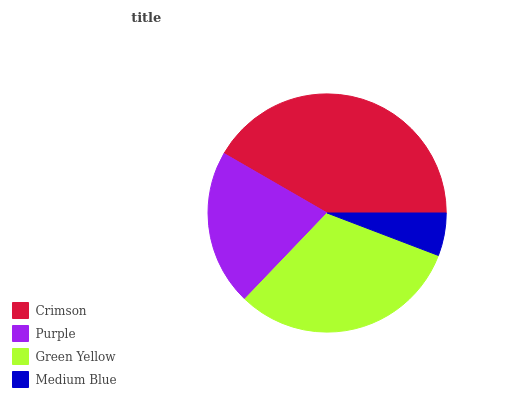Is Medium Blue the minimum?
Answer yes or no. Yes. Is Crimson the maximum?
Answer yes or no. Yes. Is Purple the minimum?
Answer yes or no. No. Is Purple the maximum?
Answer yes or no. No. Is Crimson greater than Purple?
Answer yes or no. Yes. Is Purple less than Crimson?
Answer yes or no. Yes. Is Purple greater than Crimson?
Answer yes or no. No. Is Crimson less than Purple?
Answer yes or no. No. Is Green Yellow the high median?
Answer yes or no. Yes. Is Purple the low median?
Answer yes or no. Yes. Is Medium Blue the high median?
Answer yes or no. No. Is Medium Blue the low median?
Answer yes or no. No. 